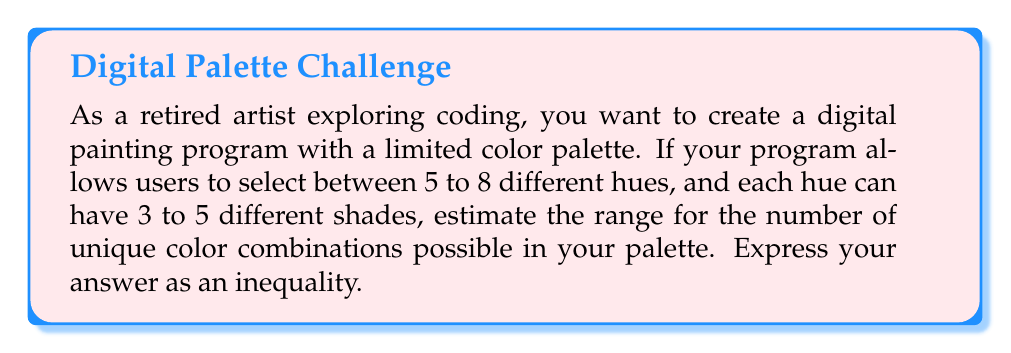Help me with this question. Let's approach this step-by-step:

1) First, let's consider the minimum number of combinations:
   - Minimum number of hues: 5
   - Minimum number of shades per hue: 3
   Minimum combinations = $5 \times 3 = 15$

2) Now, let's consider the maximum number of combinations:
   - Maximum number of hues: 8
   - Maximum number of shades per hue: 5
   Maximum combinations = $8 \times 5 = 40$

3) Therefore, the range of possible combinations is from 15 to 40.

4) To express this as an inequality, we can write:

   $15 \leq x \leq 40$

   where $x$ represents the number of unique color combinations.

5) This inequality can be read as "x is greater than or equal to 15 and less than or equal to 40."

This approach allows for creativity within constraints, mirroring the balance between artistic expression and the limitations of digital tools.
Answer: $15 \leq x \leq 40$ 